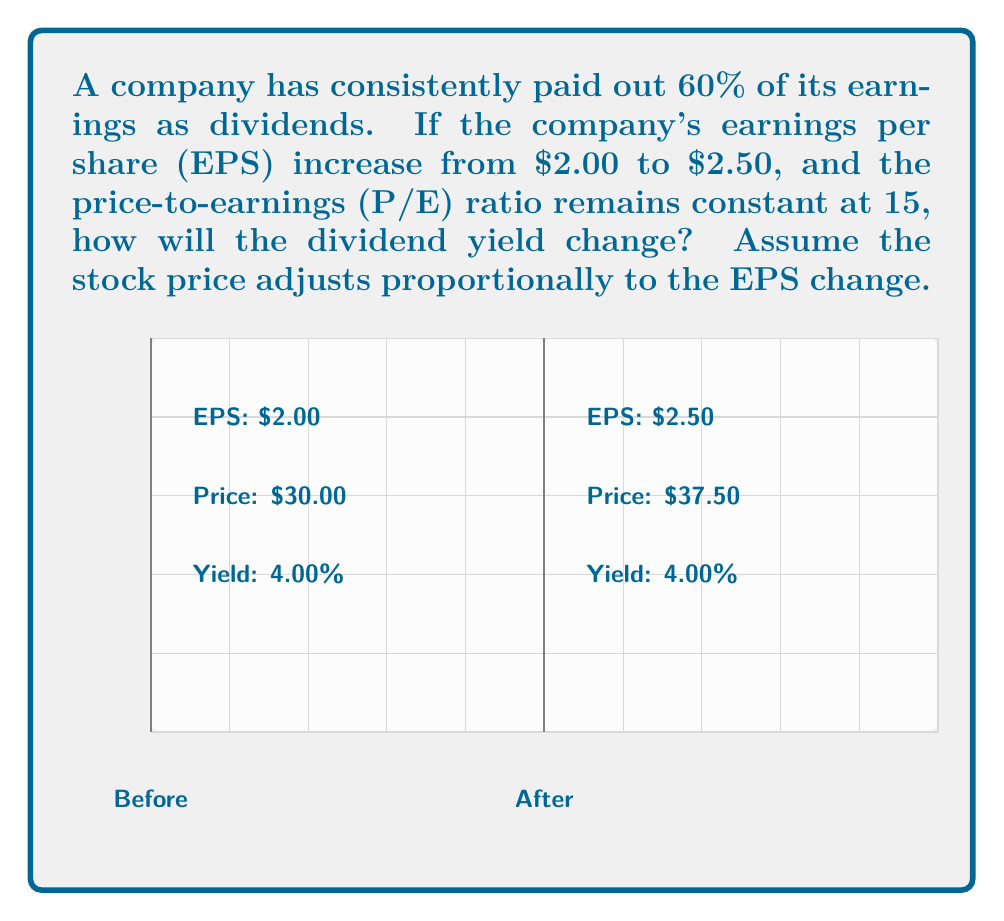Show me your answer to this math problem. Let's approach this step-by-step:

1) First, we need to calculate the initial dividend:
   Initial EPS = $2.00
   Payout ratio = 60%
   Initial dividend = $2.00 * 0.60 = $1.20

2) Calculate the initial stock price:
   P/E ratio = 15
   Initial stock price = $2.00 * 15 = $30.00

3) Calculate the initial dividend yield:
   Initial dividend yield = $1.20 / $30.00 = 0.04 or 4%

4) Now, let's calculate the new dividend:
   New EPS = $2.50
   New dividend = $2.50 * 0.60 = $1.50

5) Calculate the new stock price:
   New stock price = $2.50 * 15 = $37.50

6) Calculate the new dividend yield:
   New dividend yield = $1.50 / $37.50 = 0.04 or 4%

7) Compare the initial and new dividend yields:
   Initial yield = 4%
   New yield = 4%

The dividend yield remains unchanged at 4%. This is because both the dividend and the stock price increased proportionally with the increase in EPS, given that the P/E ratio and payout ratio remained constant.

This demonstrates that if a company maintains a constant payout ratio and P/E ratio, changes in EPS will not affect the dividend yield, as both the dividend and stock price will adjust proportionally.
Answer: The dividend yield remains unchanged at 4%. 